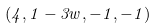<formula> <loc_0><loc_0><loc_500><loc_500>( 4 , 1 - 3 w , - 1 , - 1 )</formula> 